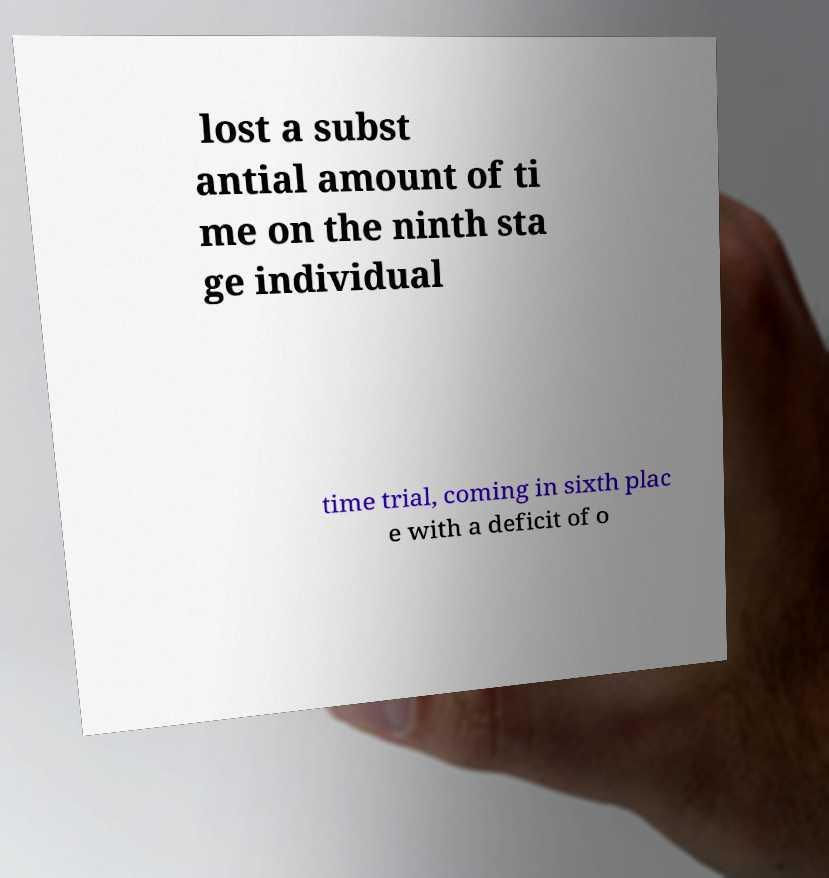Can you read and provide the text displayed in the image?This photo seems to have some interesting text. Can you extract and type it out for me? lost a subst antial amount of ti me on the ninth sta ge individual time trial, coming in sixth plac e with a deficit of o 